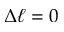Convert formula to latex. <formula><loc_0><loc_0><loc_500><loc_500>\Delta \ell = 0</formula> 